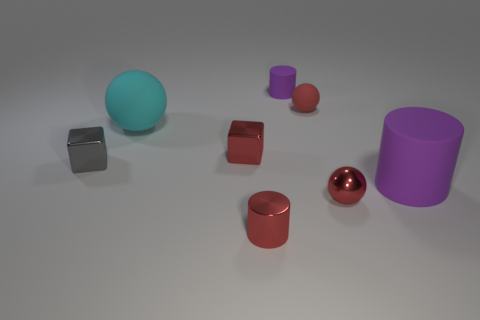There is a matte cylinder that is in front of the small red object that is behind the big cyan thing; what number of large cyan things are behind it?
Your answer should be very brief. 1. What number of tiny things are both in front of the tiny matte ball and to the right of the small purple cylinder?
Offer a terse response. 1. Are there any other things of the same color as the tiny metallic ball?
Provide a short and direct response. Yes. What number of metal objects are either big purple cylinders or tiny purple objects?
Your answer should be compact. 0. The tiny red object behind the small shiny cube on the right side of the large object that is left of the big purple rubber thing is made of what material?
Your response must be concise. Rubber. The purple object that is on the left side of the purple object that is in front of the tiny purple rubber cylinder is made of what material?
Your answer should be compact. Rubber. There is a rubber thing to the right of the metal sphere; does it have the same size as the matte ball that is behind the large cyan sphere?
Offer a very short reply. No. Are there any other things that are made of the same material as the small purple thing?
Your answer should be very brief. Yes. How many large objects are red objects or gray metal cubes?
Offer a terse response. 0. What number of objects are either spheres that are behind the small metal sphere or small purple matte objects?
Provide a short and direct response. 3. 